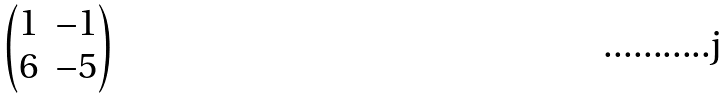Convert formula to latex. <formula><loc_0><loc_0><loc_500><loc_500>\begin{pmatrix} 1 & - 1 \\ 6 & - 5 \end{pmatrix}</formula> 